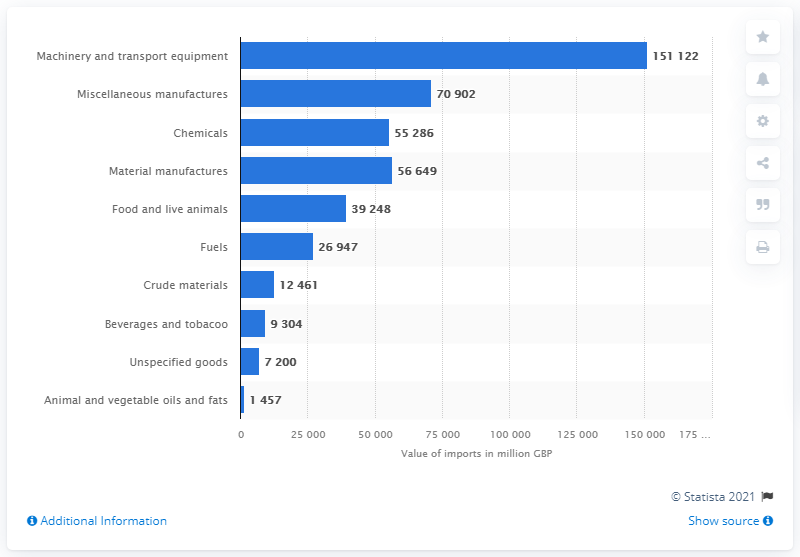Identify some key points in this picture. In the United Kingdom, the commodity with the highest value of goods imports in 2020/21 was machinery and transport equipment, worth over £160 billion. In 2020, miscellaneous manufactures were the second most valuable commodity imported into the UK, after crude oil. The UK imported 151,122 pounds of machinery and transport equipment between April 2020 and April 2021. In the year 2020/21, the total amount of unspecified goods imports for animal and vegetable oils and fats in the UK was 8,657. 